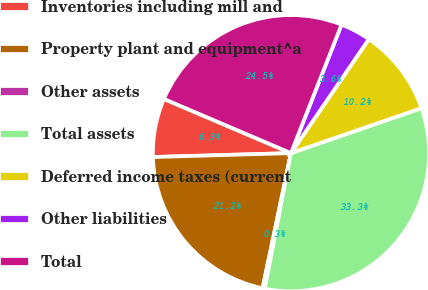Convert chart to OTSL. <chart><loc_0><loc_0><loc_500><loc_500><pie_chart><fcel>Inventories including mill and<fcel>Property plant and equipment^a<fcel>Other assets<fcel>Total assets<fcel>Deferred income taxes (current<fcel>Other liabilities<fcel>Total<nl><fcel>6.87%<fcel>21.25%<fcel>0.26%<fcel>33.32%<fcel>10.18%<fcel>3.57%<fcel>24.55%<nl></chart> 